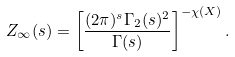<formula> <loc_0><loc_0><loc_500><loc_500>Z _ { \infty } ( s ) = \left [ \frac { ( 2 \pi ) ^ { s } \Gamma _ { 2 } ( s ) ^ { 2 } } { \Gamma ( s ) } \right ] ^ { - \chi ( X ) } .</formula> 